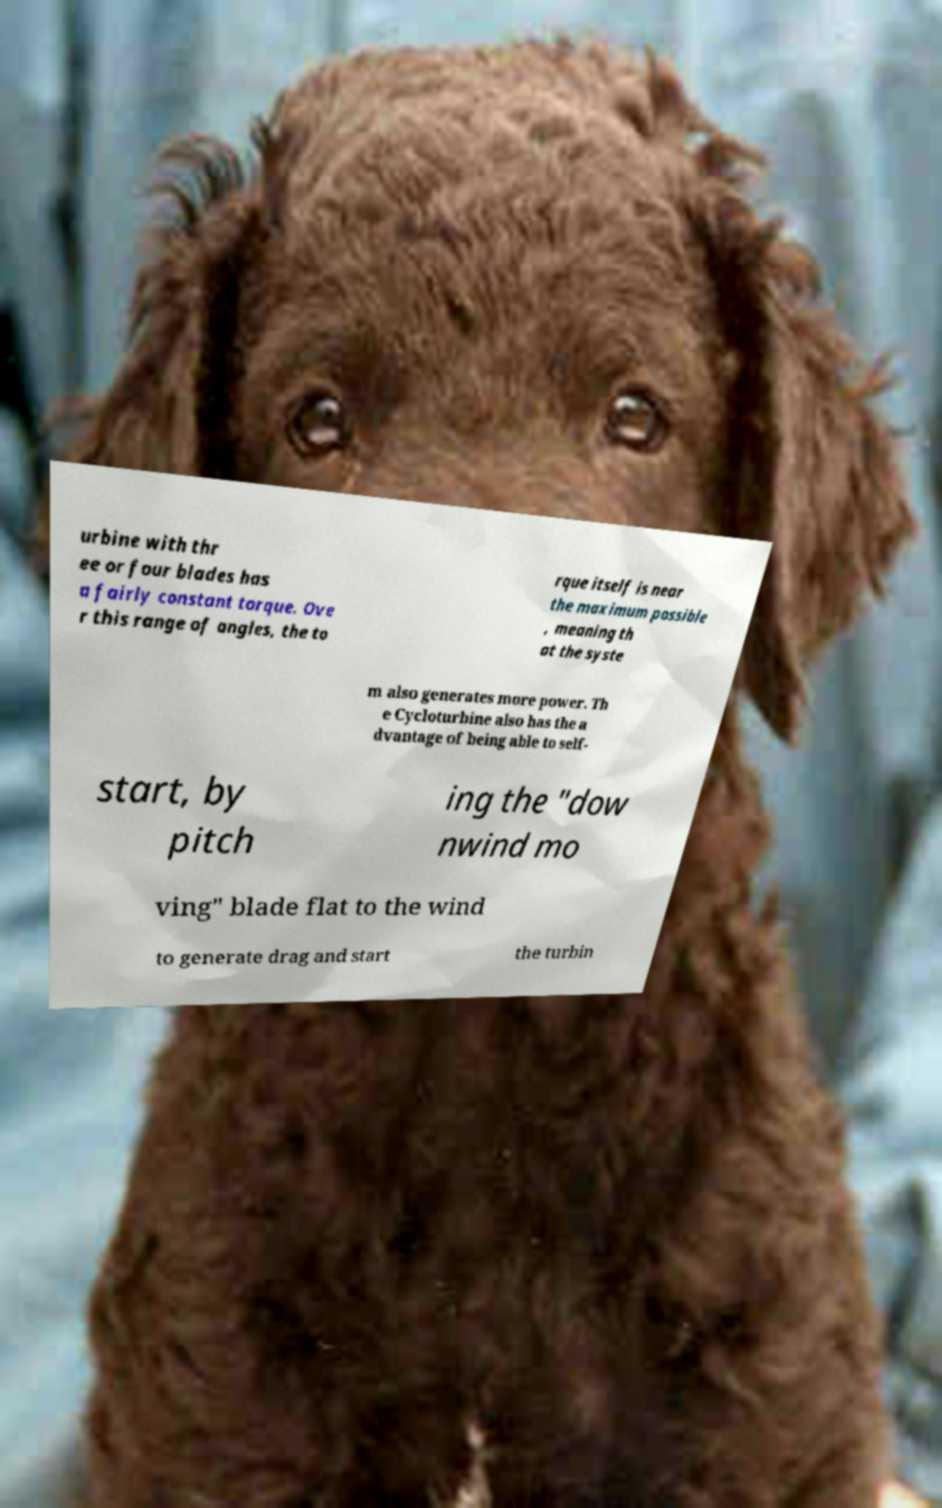Could you assist in decoding the text presented in this image and type it out clearly? urbine with thr ee or four blades has a fairly constant torque. Ove r this range of angles, the to rque itself is near the maximum possible , meaning th at the syste m also generates more power. Th e Cycloturbine also has the a dvantage of being able to self- start, by pitch ing the "dow nwind mo ving" blade flat to the wind to generate drag and start the turbin 